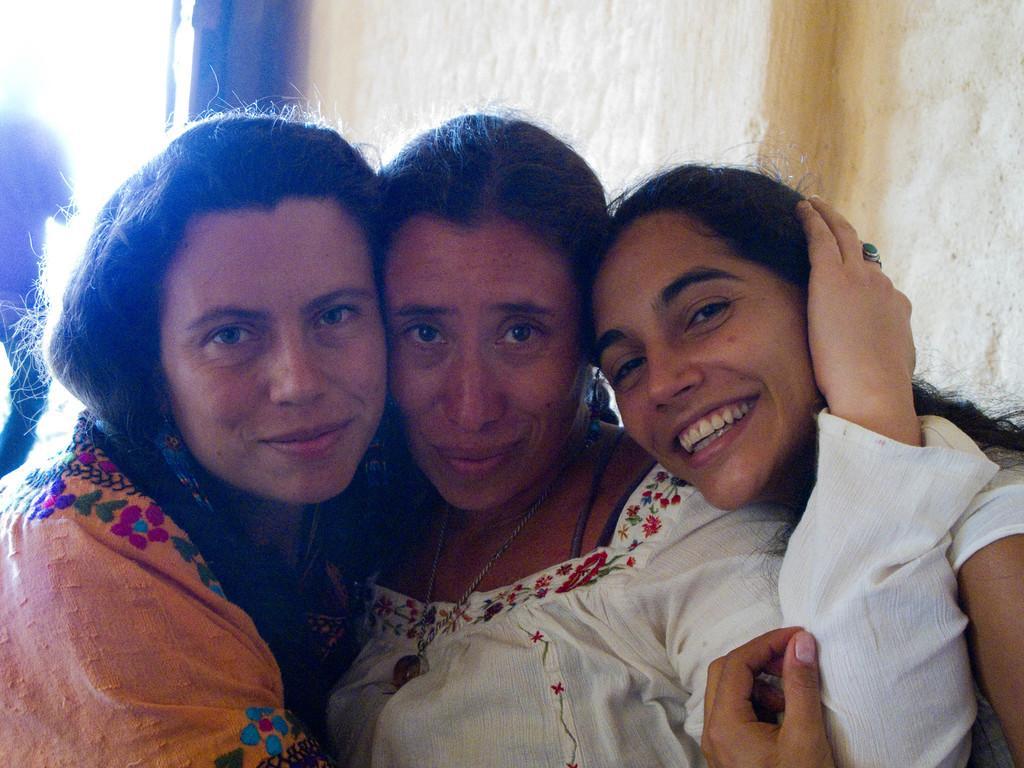Describe this image in one or two sentences. In this image there are three women, in the background there is a wall. 